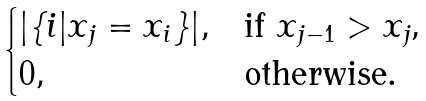Convert formula to latex. <formula><loc_0><loc_0><loc_500><loc_500>\begin{cases} | \{ i | x _ { j } = x _ { i } \} | , & \text {if $x_{j-1}>x_{j}$,} \\ 0 , & \text {otherwise} . \end{cases}</formula> 